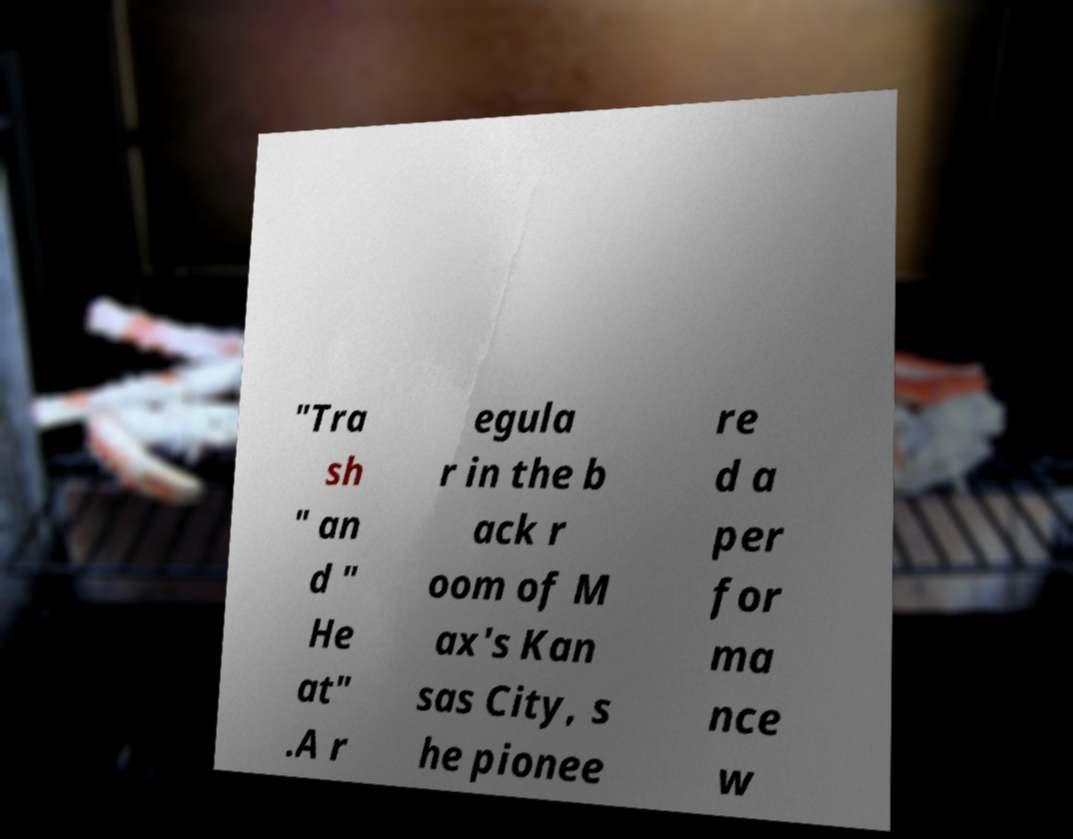There's text embedded in this image that I need extracted. Can you transcribe it verbatim? "Tra sh " an d " He at" .A r egula r in the b ack r oom of M ax's Kan sas City, s he pionee re d a per for ma nce w 